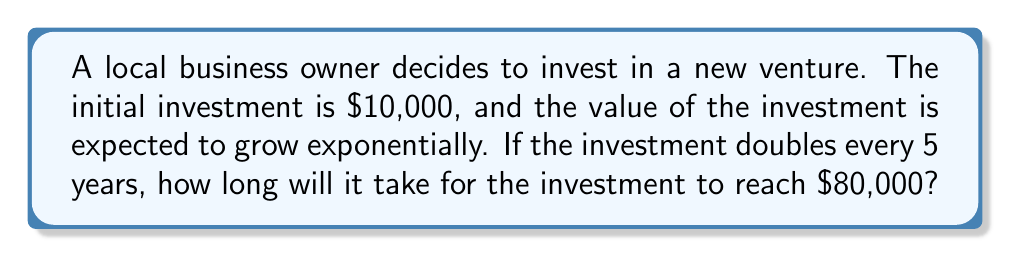Give your solution to this math problem. Let's approach this step-by-step:

1) We can model this situation with the exponential growth formula:
   $A = P(1 + r)^t$
   where A is the final amount, P is the principal (initial investment), r is the growth rate, and t is the time.

2) We know:
   P = $10,000
   A = $80,000
   The investment doubles every 5 years, so in 5 years, it grows by a factor of 2.

3) To find r, we can use:
   $2 = (1 + r)^5$
   $\sqrt[5]{2} = 1 + r$
   $r = \sqrt[5]{2} - 1 \approx 0.1487$ or about 14.87% per year

4) Now we can set up our equation:
   $80000 = 10000(1 + 0.1487)^t$

5) Simplify:
   $8 = (1.1487)^t$

6) Take the natural log of both sides:
   $\ln(8) = t \cdot \ln(1.1487)$

7) Solve for t:
   $t = \frac{\ln(8)}{\ln(1.1487)} \approx 15.0004$ years
Answer: 15 years 